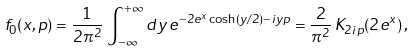<formula> <loc_0><loc_0><loc_500><loc_500>f _ { 0 } ( x , p ) = \frac { 1 } { 2 \pi ^ { 2 } } \, \int _ { - \infty } ^ { + \infty } d y \, e ^ { - 2 e ^ { x } \cosh ( y / 2 ) - i y p } = \frac { 2 } { \pi ^ { 2 } } \, K _ { 2 i p } ( 2 e ^ { x } ) \, ,</formula> 